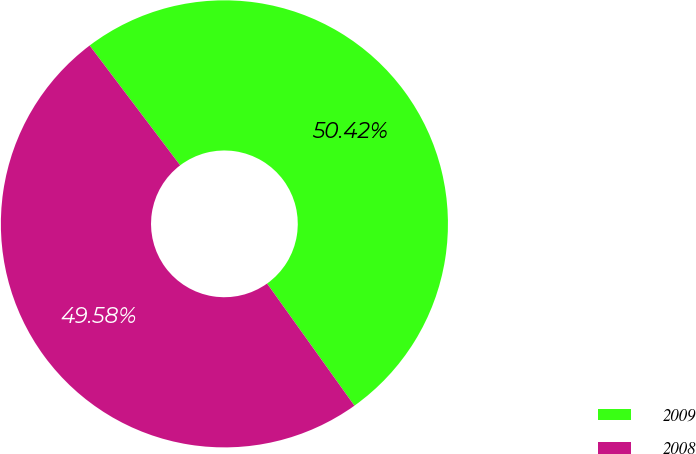<chart> <loc_0><loc_0><loc_500><loc_500><pie_chart><fcel>2009<fcel>2008<nl><fcel>50.42%<fcel>49.58%<nl></chart> 